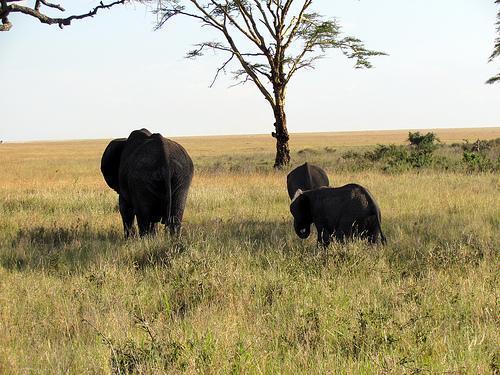How many elephants are shown?
Give a very brief answer. 3. How many elephants are in the picture?
Give a very brief answer. 3. How many adult elephants are present?
Give a very brief answer. 1. How many elephants?
Give a very brief answer. 3. How many trees?
Give a very brief answer. 1. How many elephant tails are showing?
Give a very brief answer. 3. 